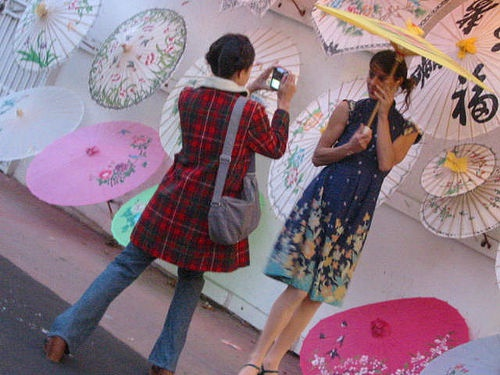Describe the objects in this image and their specific colors. I can see people in lavender, black, maroon, and gray tones, people in lavender, black, gray, and navy tones, umbrella in lavender, darkgray, lightpink, and gray tones, umbrella in lavender, lightpink, darkgray, black, and maroon tones, and umbrella in lavender, brown, purple, and violet tones in this image. 